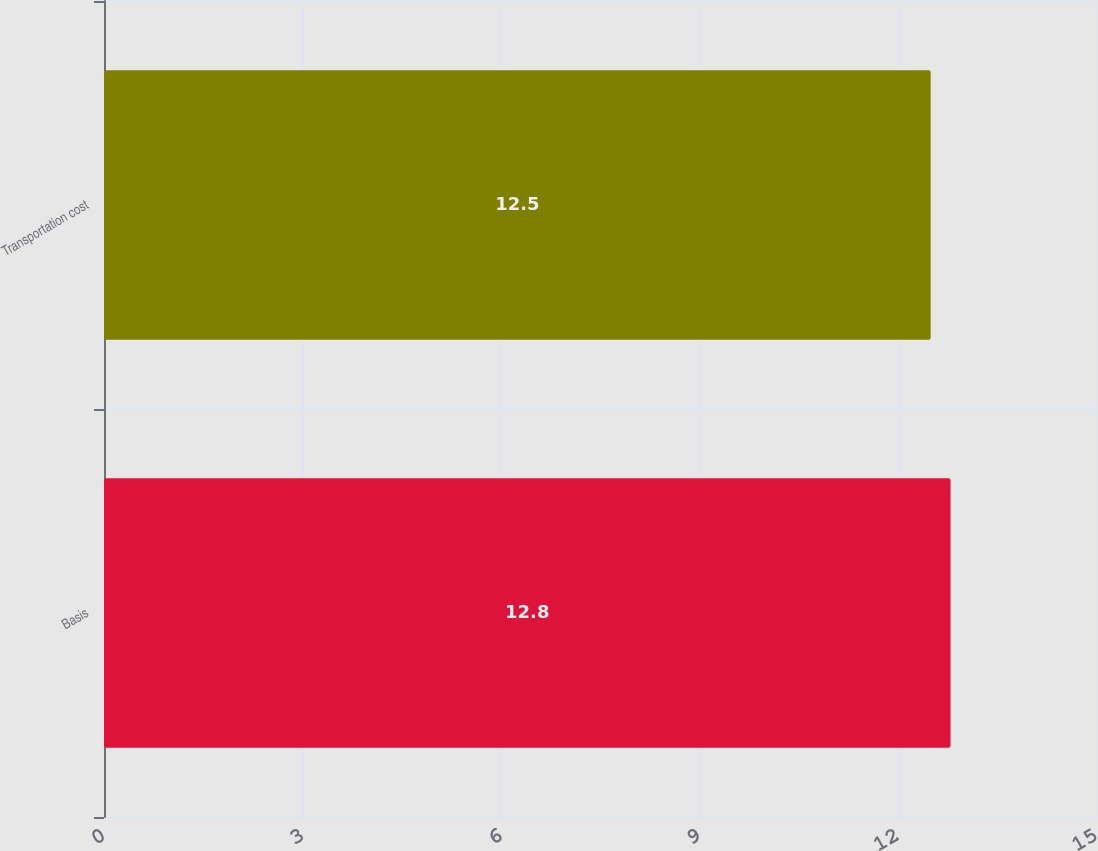Convert chart to OTSL. <chart><loc_0><loc_0><loc_500><loc_500><bar_chart><fcel>Basis<fcel>Transportation cost<nl><fcel>12.8<fcel>12.5<nl></chart> 